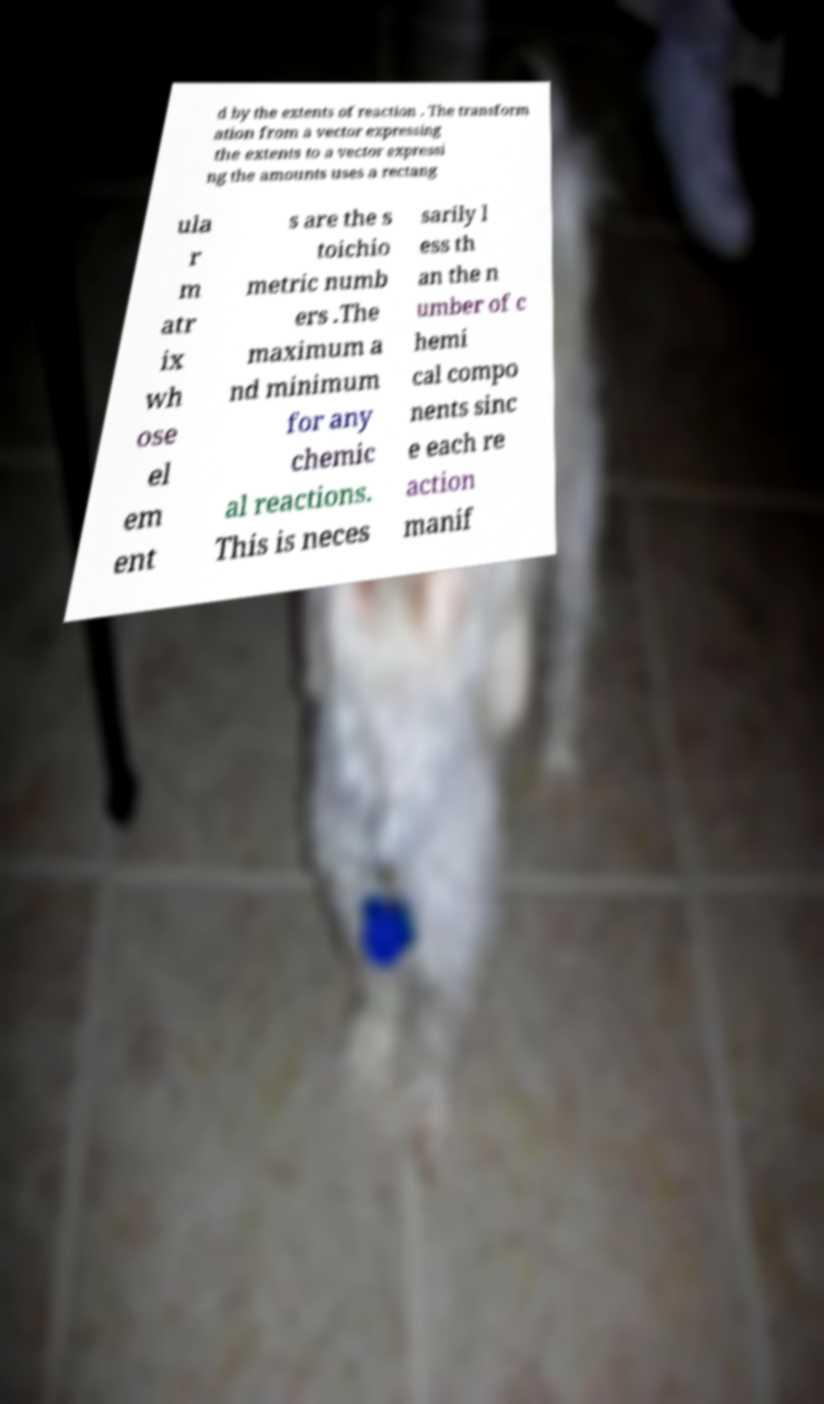Can you accurately transcribe the text from the provided image for me? d by the extents of reaction . The transform ation from a vector expressing the extents to a vector expressi ng the amounts uses a rectang ula r m atr ix wh ose el em ent s are the s toichio metric numb ers .The maximum a nd minimum for any chemic al reactions. This is neces sarily l ess th an the n umber of c hemi cal compo nents sinc e each re action manif 